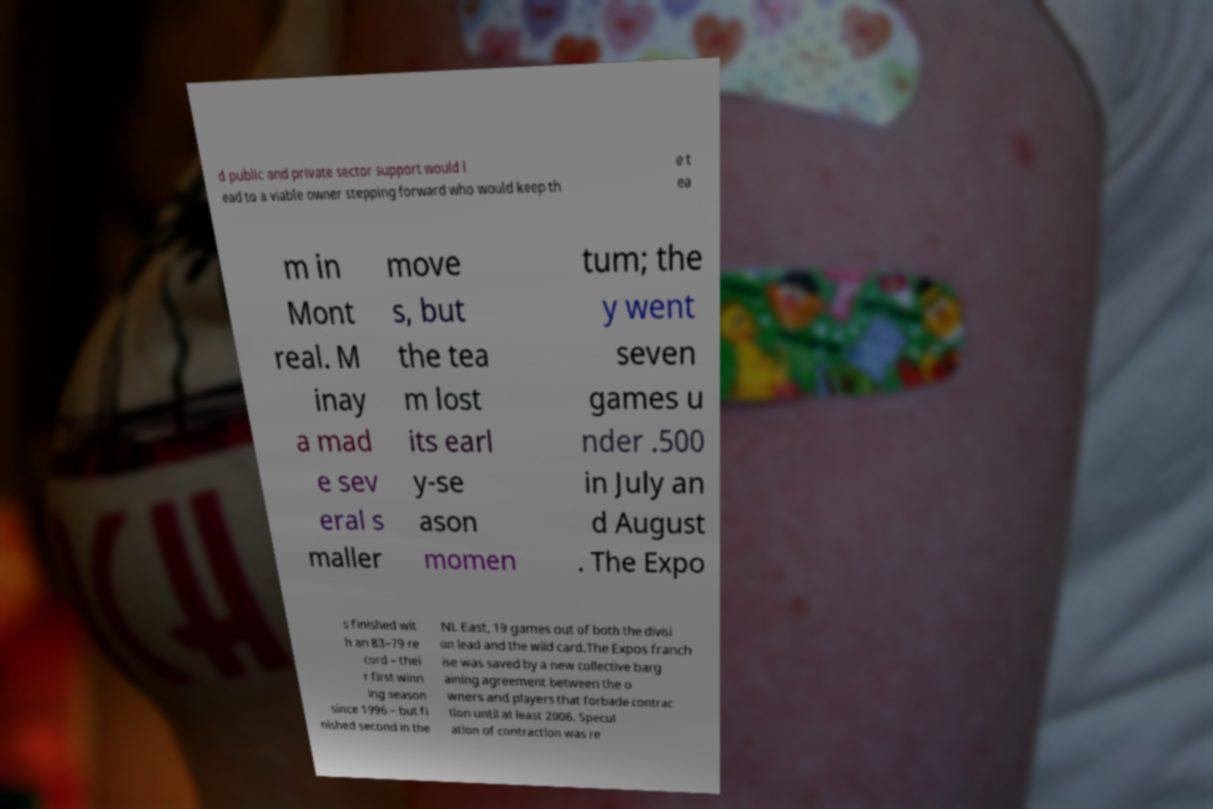Can you read and provide the text displayed in the image?This photo seems to have some interesting text. Can you extract and type it out for me? d public and private sector support would l ead to a viable owner stepping forward who would keep th e t ea m in Mont real. M inay a mad e sev eral s maller move s, but the tea m lost its earl y-se ason momen tum; the y went seven games u nder .500 in July an d August . The Expo s finished wit h an 83–79 re cord – thei r first winn ing season since 1996 – but fi nished second in the NL East, 19 games out of both the divisi on lead and the wild card.The Expos franch ise was saved by a new collective barg aining agreement between the o wners and players that forbade contrac tion until at least 2006. Specul ation of contraction was re 